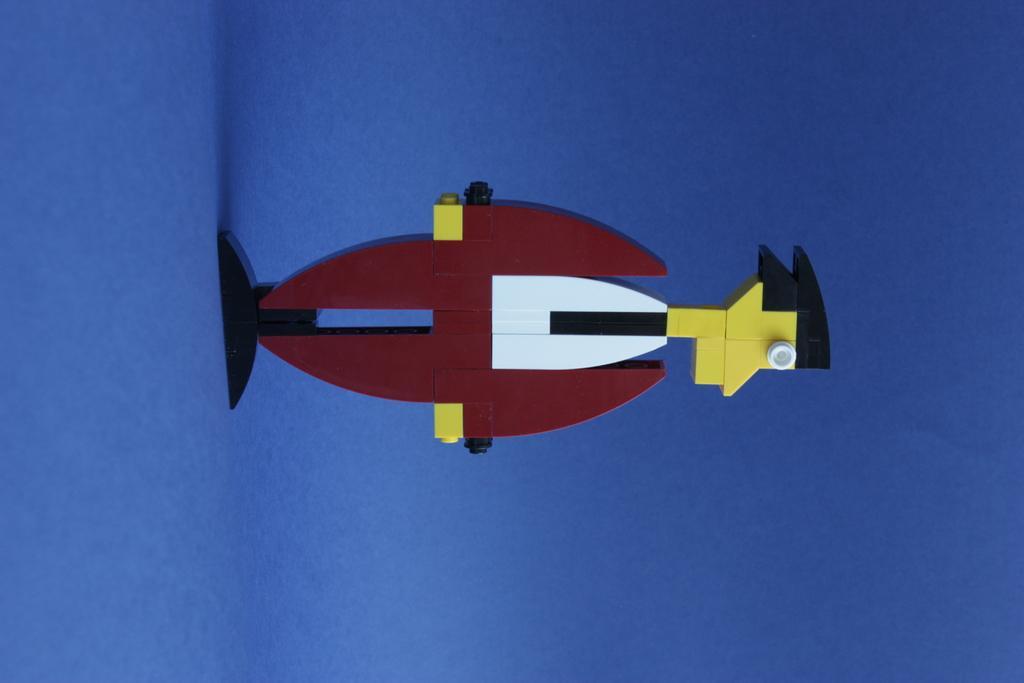In one or two sentences, can you explain what this image depicts? In this image I see a thing which is of white, maroon, yellow and black in color and it is on the blue surface. 